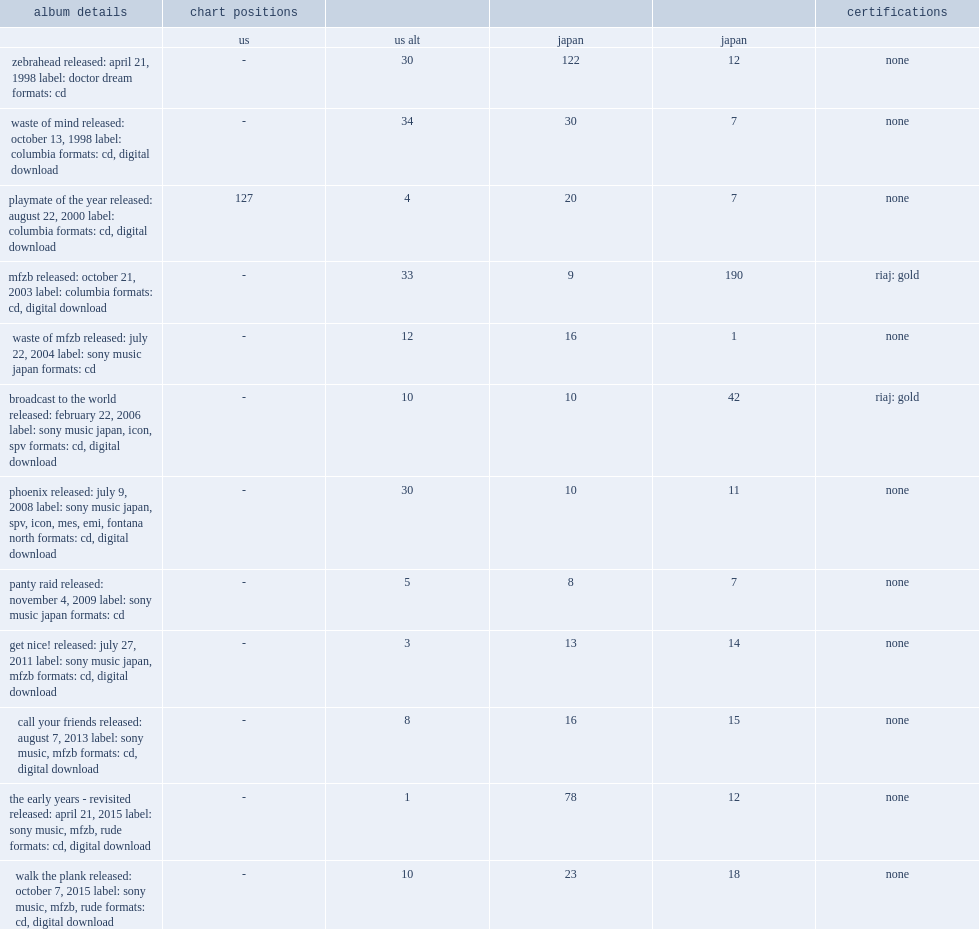What are the chart positions for zebrahead's playmate of the year album on the u.s and japanese charts? 127.0 4.0 20.0. 